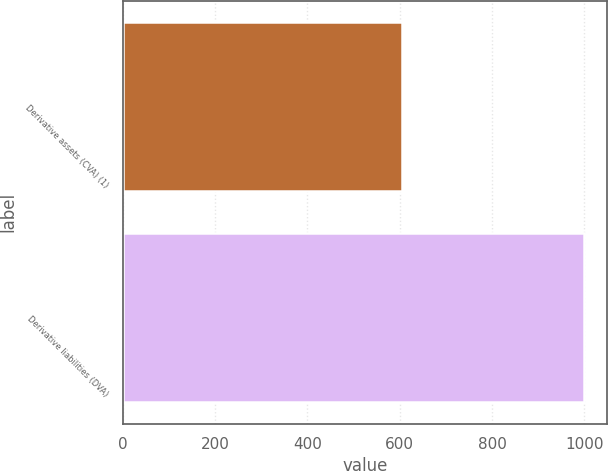<chart> <loc_0><loc_0><loc_500><loc_500><bar_chart><fcel>Derivative assets (CVA) (1)<fcel>Derivative liabilities (DVA)<nl><fcel>606<fcel>1000<nl></chart> 